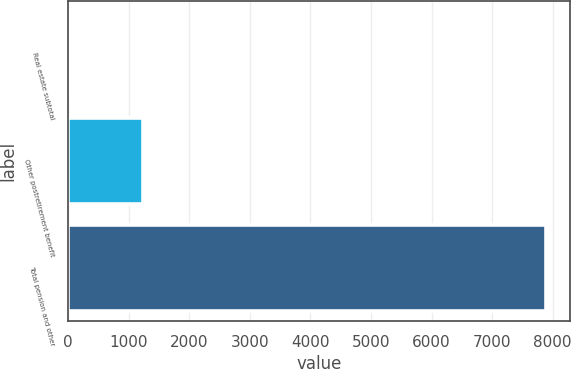<chart> <loc_0><loc_0><loc_500><loc_500><bar_chart><fcel>Real estate subtotal<fcel>Other postretirement benefit<fcel>Total pension and other<nl><fcel>8<fcel>1235<fcel>7889<nl></chart> 